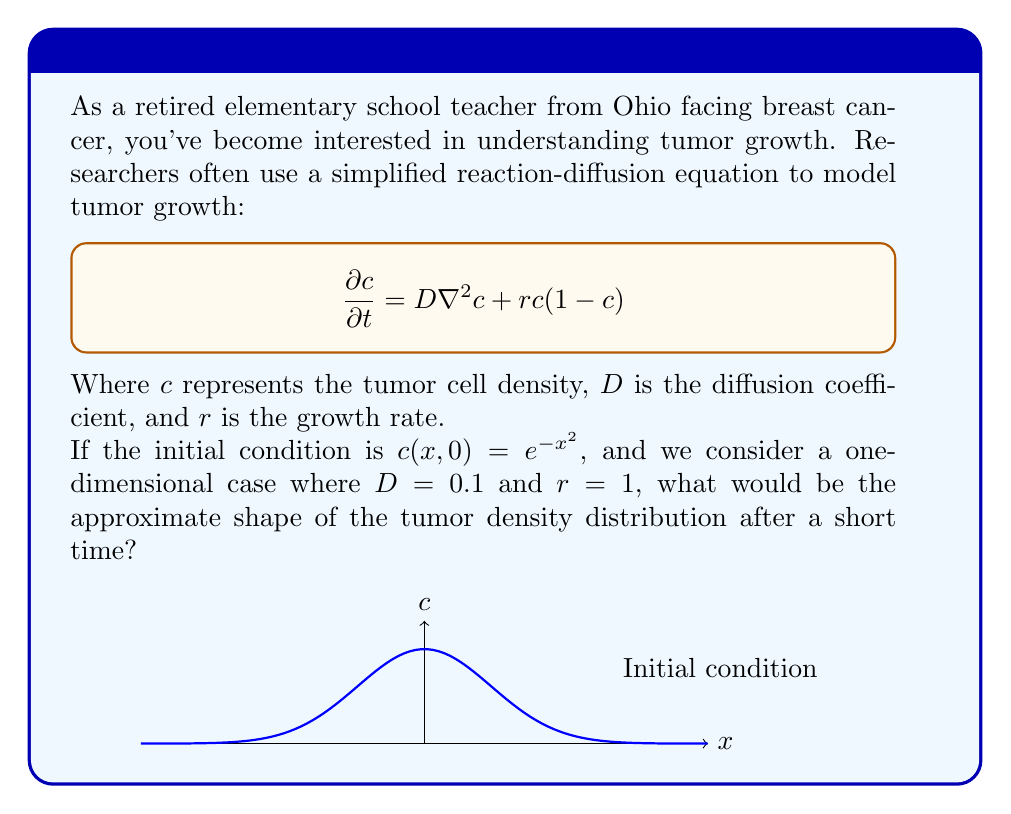Solve this math problem. Let's break this down step-by-step:

1) The reaction-diffusion equation given is:

   $$\frac{\partial c}{\partial t} = D\nabla^2c + rc(1-c)$$

2) In the one-dimensional case, $\nabla^2c$ becomes $\frac{\partial^2c}{\partial x^2}$, so our equation is:

   $$\frac{\partial c}{\partial t} = D\frac{\partial^2c}{\partial x^2} + rc(1-c)$$

3) We're given that $D=0.1$ and $r=1$, so:

   $$\frac{\partial c}{\partial t} = 0.1\frac{\partial^2c}{\partial x^2} + c(1-c)$$

4) The initial condition is $c(x,0) = e^{-x^2}$, which is a Gaussian distribution centered at $x=0$.

5) After a short time, two processes will occur:
   - Diffusion (represented by the $0.1\frac{\partial^2c}{\partial x^2}$ term) will cause the tumor to spread out.
   - Growth (represented by the $c(1-c)$ term) will cause the tumor density to increase, especially where $c$ is not close to 1.

6) The diffusion term will flatten the initial Gaussian curve slightly.

7) The growth term will increase the height of the curve, especially in regions where $c$ is not close to 1 (i.e., away from the center).

8) The combination of these effects will result in a slightly wider and taller curve that still resembles a Gaussian distribution.
Answer: A wider and taller Gaussian-like curve 